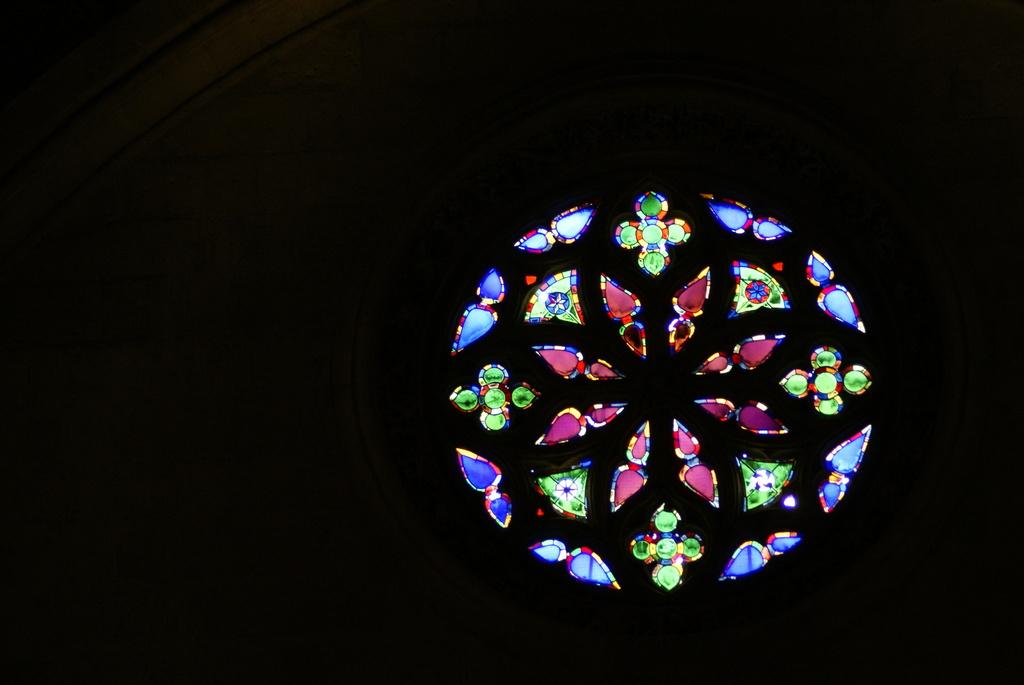What type of decorative item can be seen in the image? There is a decorative light item in the image. What can be observed about the background of the image? The background of the image is dark. What type of dinner is being served by the aunt in the image? There is no dinner or aunt present in the image; it only features a decorative light item and a dark background. 